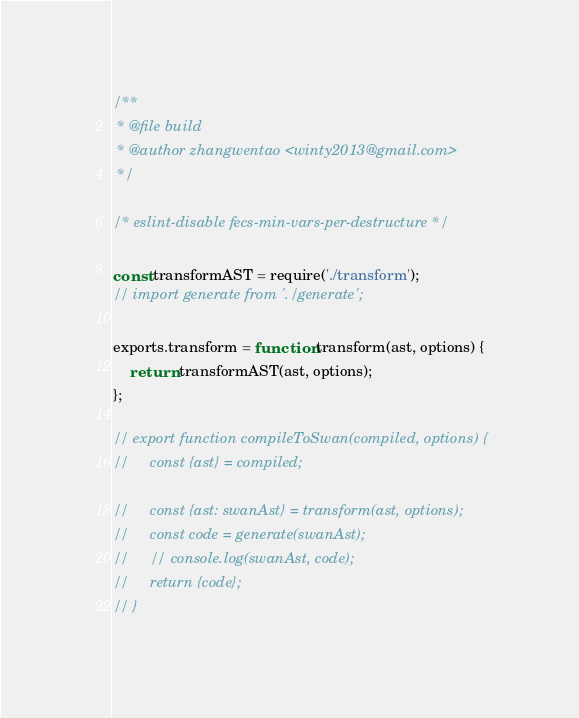Convert code to text. <code><loc_0><loc_0><loc_500><loc_500><_JavaScript_>/**
 * @file build
 * @author zhangwentao <winty2013@gmail.com>
 */

/* eslint-disable fecs-min-vars-per-destructure */

const transformAST = require('./transform');
// import generate from './generate';

exports.transform = function transform(ast, options) {
    return transformAST(ast, options);
};

// export function compileToSwan(compiled, options) {
//     const {ast} = compiled;

//     const {ast: swanAst} = transform(ast, options);
//     const code = generate(swanAst);
//     // console.log(swanAst, code);
//     return {code};
// }
</code> 